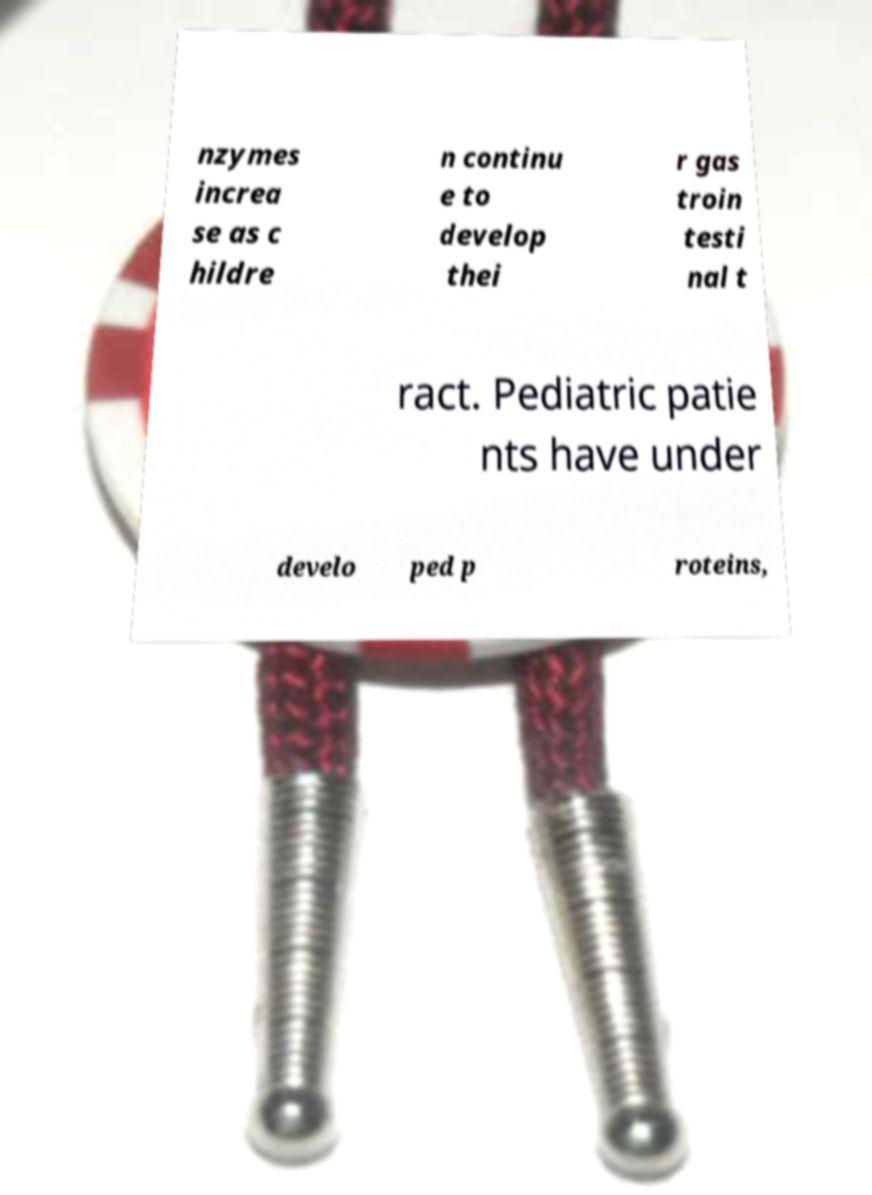Could you extract and type out the text from this image? nzymes increa se as c hildre n continu e to develop thei r gas troin testi nal t ract. Pediatric patie nts have under develo ped p roteins, 